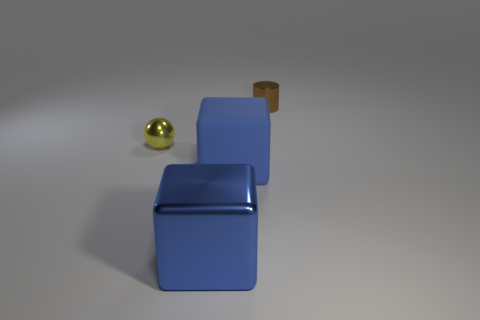Add 3 metallic objects. How many objects exist? 7 Subtract all balls. How many objects are left? 3 Subtract all small brown shiny things. Subtract all blue cubes. How many objects are left? 1 Add 1 blue objects. How many blue objects are left? 3 Add 4 large brown shiny blocks. How many large brown shiny blocks exist? 4 Subtract 1 brown cylinders. How many objects are left? 3 